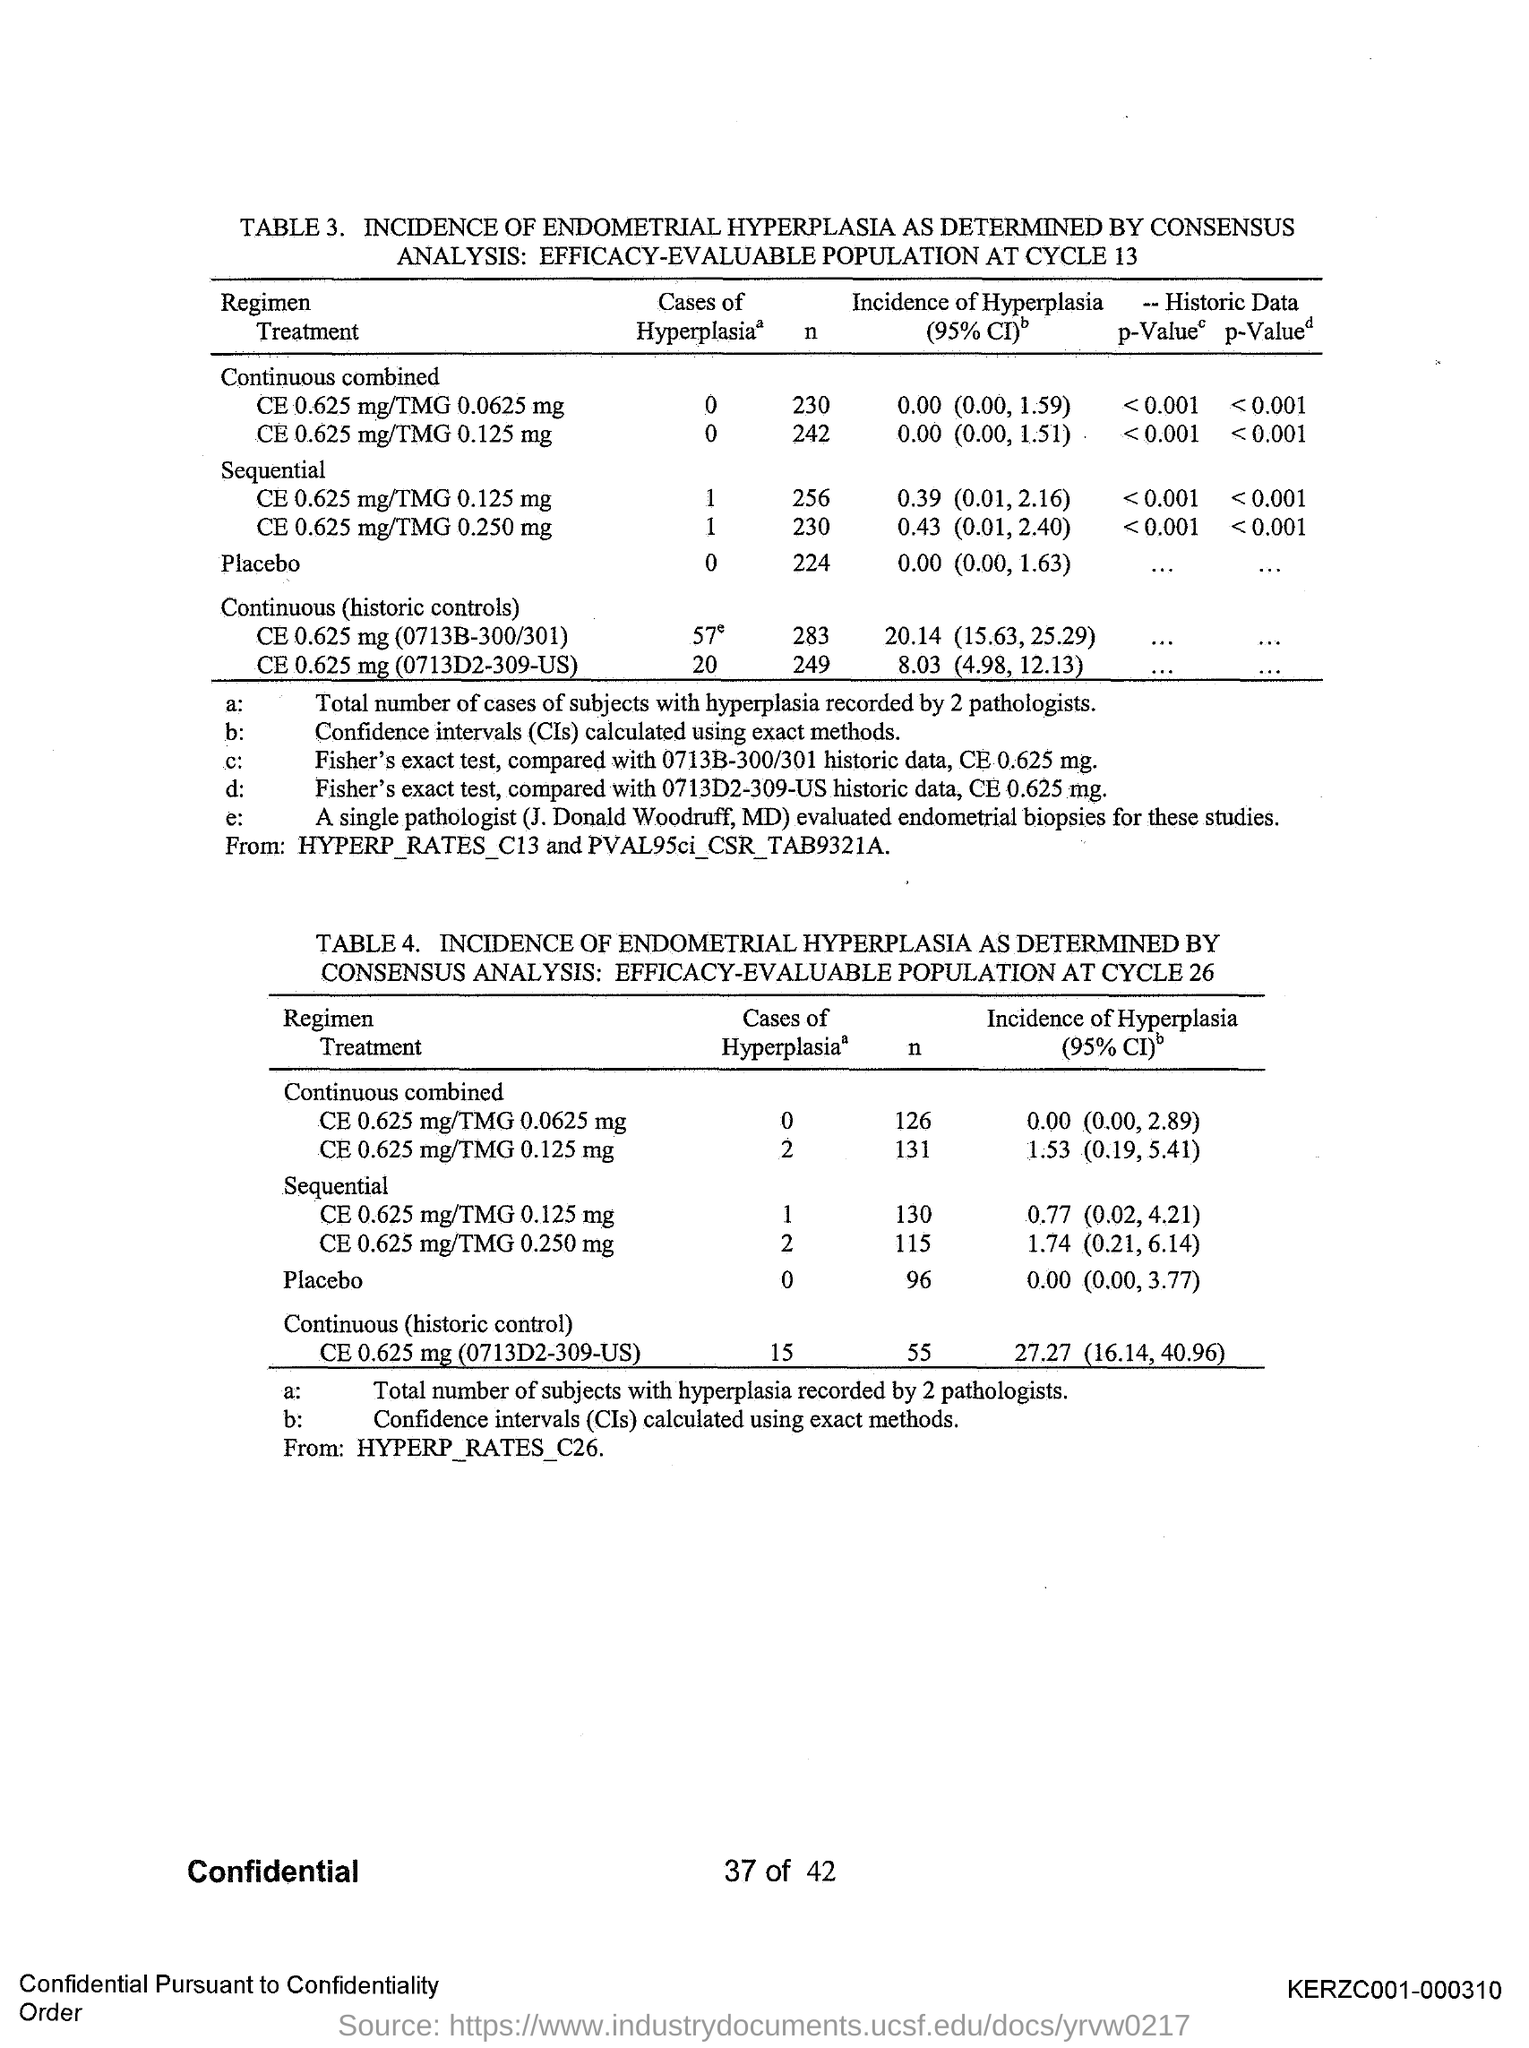What is the full form of CIs?
Offer a terse response. CONFIDENCE INTERVALS. What is the number of the first table?
Provide a short and direct response. 3. What is the number of the second table?
Offer a very short reply. 4. 